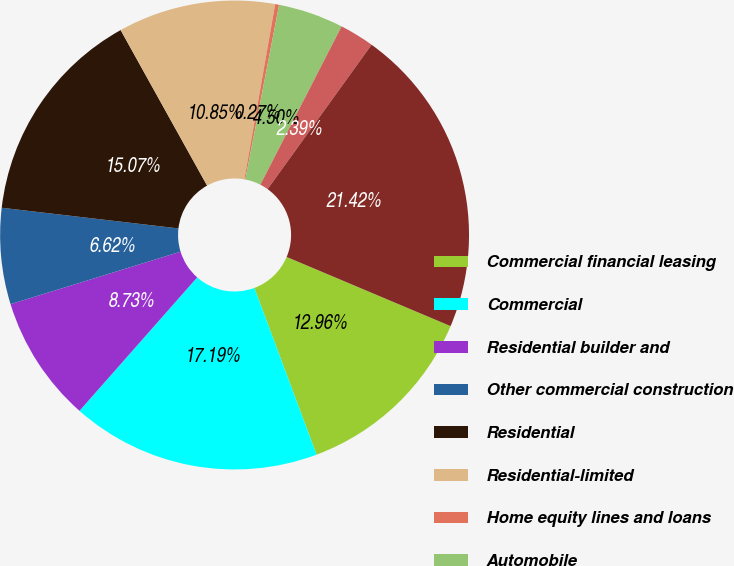Convert chart. <chart><loc_0><loc_0><loc_500><loc_500><pie_chart><fcel>Commercial financial leasing<fcel>Commercial<fcel>Residential builder and<fcel>Other commercial construction<fcel>Residential<fcel>Residential-limited<fcel>Home equity lines and loans<fcel>Automobile<fcel>Other<fcel>Total<nl><fcel>12.96%<fcel>17.19%<fcel>8.73%<fcel>6.62%<fcel>15.07%<fcel>10.85%<fcel>0.27%<fcel>4.5%<fcel>2.39%<fcel>21.42%<nl></chart> 